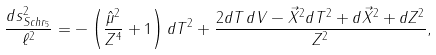Convert formula to latex. <formula><loc_0><loc_0><loc_500><loc_500>\frac { d s ^ { 2 } _ { S c h r _ { 5 } } } { \ell ^ { 2 } } = - \left ( \frac { \hat { \mu } ^ { 2 } } { Z ^ { 4 } } + 1 \right ) d T ^ { 2 } + \frac { 2 d T \, d V - \vec { X } ^ { 2 } d T ^ { 2 } + d \vec { X } ^ { 2 } + d Z ^ { 2 } } { Z ^ { 2 } } ,</formula> 